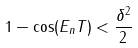<formula> <loc_0><loc_0><loc_500><loc_500>1 - \cos ( E _ { n } T ) < \frac { \delta ^ { 2 } } { 2 }</formula> 